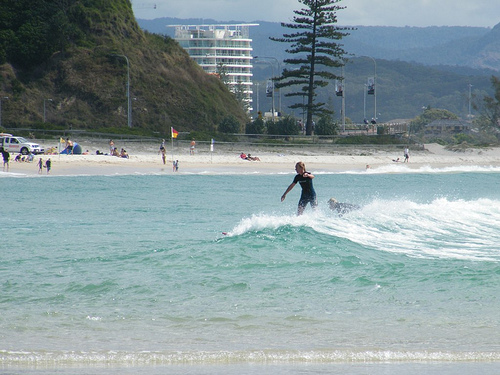Please provide the bounding box coordinate of the region this sentence describes: person standing on a surf board. The bounding box coordinates for the person standing on a surfboard are [0.55, 0.43, 0.65, 0.57]. They capture the entire region where the person is balancing on the surfboard amidst the waves. 